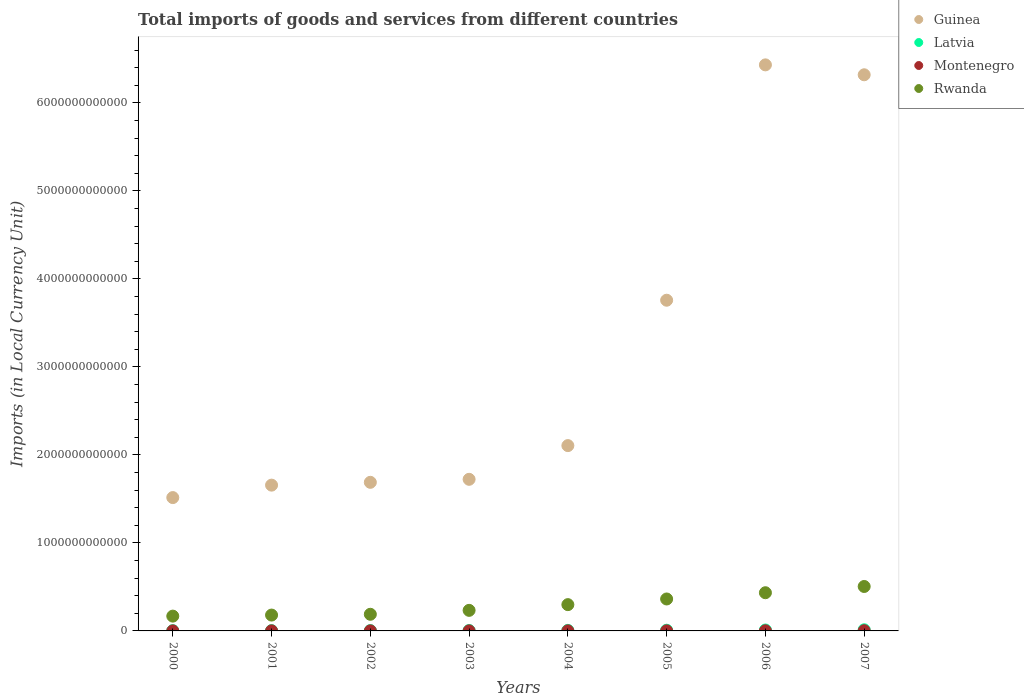How many different coloured dotlines are there?
Provide a short and direct response. 4. What is the Amount of goods and services imports in Rwanda in 2001?
Offer a very short reply. 1.80e+11. Across all years, what is the maximum Amount of goods and services imports in Latvia?
Your answer should be very brief. 1.30e+1. Across all years, what is the minimum Amount of goods and services imports in Rwanda?
Give a very brief answer. 1.68e+11. In which year was the Amount of goods and services imports in Rwanda maximum?
Your answer should be very brief. 2007. In which year was the Amount of goods and services imports in Montenegro minimum?
Your answer should be very brief. 2000. What is the total Amount of goods and services imports in Montenegro in the graph?
Make the answer very short. 8.97e+09. What is the difference between the Amount of goods and services imports in Montenegro in 2004 and that in 2006?
Your response must be concise. -7.30e+08. What is the difference between the Amount of goods and services imports in Latvia in 2003 and the Amount of goods and services imports in Rwanda in 2000?
Make the answer very short. -1.64e+11. What is the average Amount of goods and services imports in Guinea per year?
Ensure brevity in your answer.  3.15e+12. In the year 2003, what is the difference between the Amount of goods and services imports in Montenegro and Amount of goods and services imports in Rwanda?
Offer a very short reply. -2.33e+11. What is the ratio of the Amount of goods and services imports in Guinea in 2000 to that in 2006?
Provide a succinct answer. 0.24. Is the Amount of goods and services imports in Guinea in 2005 less than that in 2006?
Provide a succinct answer. Yes. What is the difference between the highest and the second highest Amount of goods and services imports in Rwanda?
Give a very brief answer. 7.10e+1. What is the difference between the highest and the lowest Amount of goods and services imports in Rwanda?
Offer a terse response. 3.37e+11. Does the Amount of goods and services imports in Montenegro monotonically increase over the years?
Give a very brief answer. No. Is the Amount of goods and services imports in Montenegro strictly greater than the Amount of goods and services imports in Guinea over the years?
Your answer should be very brief. No. Is the Amount of goods and services imports in Montenegro strictly less than the Amount of goods and services imports in Rwanda over the years?
Your answer should be very brief. Yes. How many dotlines are there?
Give a very brief answer. 4. How many years are there in the graph?
Keep it short and to the point. 8. What is the difference between two consecutive major ticks on the Y-axis?
Keep it short and to the point. 1.00e+12. Does the graph contain grids?
Ensure brevity in your answer.  No. Where does the legend appear in the graph?
Provide a succinct answer. Top right. How many legend labels are there?
Ensure brevity in your answer.  4. How are the legend labels stacked?
Your answer should be very brief. Vertical. What is the title of the graph?
Ensure brevity in your answer.  Total imports of goods and services from different countries. Does "High income: nonOECD" appear as one of the legend labels in the graph?
Your answer should be compact. No. What is the label or title of the Y-axis?
Offer a very short reply. Imports (in Local Currency Unit). What is the Imports (in Local Currency Unit) in Guinea in 2000?
Provide a short and direct response. 1.52e+12. What is the Imports (in Local Currency Unit) in Latvia in 2000?
Offer a very short reply. 3.07e+09. What is the Imports (in Local Currency Unit) of Montenegro in 2000?
Offer a very short reply. 5.45e+08. What is the Imports (in Local Currency Unit) in Rwanda in 2000?
Offer a terse response. 1.68e+11. What is the Imports (in Local Currency Unit) in Guinea in 2001?
Give a very brief answer. 1.66e+12. What is the Imports (in Local Currency Unit) of Latvia in 2001?
Give a very brief answer. 3.61e+09. What is the Imports (in Local Currency Unit) of Montenegro in 2001?
Keep it short and to the point. 8.03e+08. What is the Imports (in Local Currency Unit) of Rwanda in 2001?
Your answer should be compact. 1.80e+11. What is the Imports (in Local Currency Unit) of Guinea in 2002?
Offer a terse response. 1.69e+12. What is the Imports (in Local Currency Unit) of Latvia in 2002?
Your response must be concise. 3.92e+09. What is the Imports (in Local Currency Unit) of Montenegro in 2002?
Your answer should be very brief. 8.14e+08. What is the Imports (in Local Currency Unit) of Rwanda in 2002?
Your response must be concise. 1.89e+11. What is the Imports (in Local Currency Unit) in Guinea in 2003?
Your answer should be very brief. 1.72e+12. What is the Imports (in Local Currency Unit) of Latvia in 2003?
Offer a terse response. 4.65e+09. What is the Imports (in Local Currency Unit) in Montenegro in 2003?
Keep it short and to the point. 7.10e+08. What is the Imports (in Local Currency Unit) in Rwanda in 2003?
Your answer should be very brief. 2.34e+11. What is the Imports (in Local Currency Unit) in Guinea in 2004?
Your answer should be compact. 2.11e+12. What is the Imports (in Local Currency Unit) in Latvia in 2004?
Your answer should be compact. 6.04e+09. What is the Imports (in Local Currency Unit) of Montenegro in 2004?
Your answer should be compact. 9.70e+08. What is the Imports (in Local Currency Unit) in Rwanda in 2004?
Your answer should be compact. 2.99e+11. What is the Imports (in Local Currency Unit) in Guinea in 2005?
Your response must be concise. 3.76e+12. What is the Imports (in Local Currency Unit) in Latvia in 2005?
Your answer should be very brief. 7.84e+09. What is the Imports (in Local Currency Unit) in Montenegro in 2005?
Provide a succinct answer. 1.11e+09. What is the Imports (in Local Currency Unit) of Rwanda in 2005?
Your response must be concise. 3.63e+11. What is the Imports (in Local Currency Unit) in Guinea in 2006?
Your answer should be very brief. 6.43e+12. What is the Imports (in Local Currency Unit) in Latvia in 2006?
Keep it short and to the point. 1.04e+1. What is the Imports (in Local Currency Unit) in Montenegro in 2006?
Provide a succinct answer. 1.70e+09. What is the Imports (in Local Currency Unit) in Rwanda in 2006?
Your response must be concise. 4.34e+11. What is the Imports (in Local Currency Unit) in Guinea in 2007?
Give a very brief answer. 6.32e+12. What is the Imports (in Local Currency Unit) in Latvia in 2007?
Offer a terse response. 1.30e+1. What is the Imports (in Local Currency Unit) of Montenegro in 2007?
Offer a very short reply. 2.32e+09. What is the Imports (in Local Currency Unit) in Rwanda in 2007?
Your answer should be compact. 5.05e+11. Across all years, what is the maximum Imports (in Local Currency Unit) of Guinea?
Make the answer very short. 6.43e+12. Across all years, what is the maximum Imports (in Local Currency Unit) in Latvia?
Provide a succinct answer. 1.30e+1. Across all years, what is the maximum Imports (in Local Currency Unit) in Montenegro?
Ensure brevity in your answer.  2.32e+09. Across all years, what is the maximum Imports (in Local Currency Unit) in Rwanda?
Your answer should be very brief. 5.05e+11. Across all years, what is the minimum Imports (in Local Currency Unit) in Guinea?
Offer a very short reply. 1.52e+12. Across all years, what is the minimum Imports (in Local Currency Unit) of Latvia?
Keep it short and to the point. 3.07e+09. Across all years, what is the minimum Imports (in Local Currency Unit) in Montenegro?
Make the answer very short. 5.45e+08. Across all years, what is the minimum Imports (in Local Currency Unit) in Rwanda?
Your answer should be very brief. 1.68e+11. What is the total Imports (in Local Currency Unit) of Guinea in the graph?
Ensure brevity in your answer.  2.52e+13. What is the total Imports (in Local Currency Unit) in Latvia in the graph?
Give a very brief answer. 5.25e+1. What is the total Imports (in Local Currency Unit) in Montenegro in the graph?
Your response must be concise. 8.97e+09. What is the total Imports (in Local Currency Unit) in Rwanda in the graph?
Your answer should be very brief. 2.37e+12. What is the difference between the Imports (in Local Currency Unit) in Guinea in 2000 and that in 2001?
Your answer should be compact. -1.41e+11. What is the difference between the Imports (in Local Currency Unit) in Latvia in 2000 and that in 2001?
Your answer should be compact. -5.40e+08. What is the difference between the Imports (in Local Currency Unit) in Montenegro in 2000 and that in 2001?
Offer a very short reply. -2.58e+08. What is the difference between the Imports (in Local Currency Unit) in Rwanda in 2000 and that in 2001?
Provide a succinct answer. -1.19e+1. What is the difference between the Imports (in Local Currency Unit) in Guinea in 2000 and that in 2002?
Offer a terse response. -1.74e+11. What is the difference between the Imports (in Local Currency Unit) in Latvia in 2000 and that in 2002?
Keep it short and to the point. -8.49e+08. What is the difference between the Imports (in Local Currency Unit) of Montenegro in 2000 and that in 2002?
Offer a very short reply. -2.70e+08. What is the difference between the Imports (in Local Currency Unit) of Rwanda in 2000 and that in 2002?
Offer a very short reply. -2.09e+1. What is the difference between the Imports (in Local Currency Unit) of Guinea in 2000 and that in 2003?
Give a very brief answer. -2.08e+11. What is the difference between the Imports (in Local Currency Unit) of Latvia in 2000 and that in 2003?
Offer a terse response. -1.57e+09. What is the difference between the Imports (in Local Currency Unit) in Montenegro in 2000 and that in 2003?
Offer a very short reply. -1.65e+08. What is the difference between the Imports (in Local Currency Unit) of Rwanda in 2000 and that in 2003?
Offer a terse response. -6.55e+1. What is the difference between the Imports (in Local Currency Unit) in Guinea in 2000 and that in 2004?
Keep it short and to the point. -5.91e+11. What is the difference between the Imports (in Local Currency Unit) of Latvia in 2000 and that in 2004?
Offer a very short reply. -2.96e+09. What is the difference between the Imports (in Local Currency Unit) of Montenegro in 2000 and that in 2004?
Ensure brevity in your answer.  -4.25e+08. What is the difference between the Imports (in Local Currency Unit) in Rwanda in 2000 and that in 2004?
Offer a very short reply. -1.30e+11. What is the difference between the Imports (in Local Currency Unit) of Guinea in 2000 and that in 2005?
Offer a terse response. -2.24e+12. What is the difference between the Imports (in Local Currency Unit) in Latvia in 2000 and that in 2005?
Make the answer very short. -4.77e+09. What is the difference between the Imports (in Local Currency Unit) in Montenegro in 2000 and that in 2005?
Provide a succinct answer. -5.64e+08. What is the difference between the Imports (in Local Currency Unit) of Rwanda in 2000 and that in 2005?
Your response must be concise. -1.95e+11. What is the difference between the Imports (in Local Currency Unit) in Guinea in 2000 and that in 2006?
Your response must be concise. -4.92e+12. What is the difference between the Imports (in Local Currency Unit) in Latvia in 2000 and that in 2006?
Offer a terse response. -7.30e+09. What is the difference between the Imports (in Local Currency Unit) in Montenegro in 2000 and that in 2006?
Provide a short and direct response. -1.16e+09. What is the difference between the Imports (in Local Currency Unit) in Rwanda in 2000 and that in 2006?
Make the answer very short. -2.66e+11. What is the difference between the Imports (in Local Currency Unit) of Guinea in 2000 and that in 2007?
Your answer should be compact. -4.80e+12. What is the difference between the Imports (in Local Currency Unit) in Latvia in 2000 and that in 2007?
Give a very brief answer. -9.91e+09. What is the difference between the Imports (in Local Currency Unit) in Montenegro in 2000 and that in 2007?
Make the answer very short. -1.78e+09. What is the difference between the Imports (in Local Currency Unit) of Rwanda in 2000 and that in 2007?
Make the answer very short. -3.37e+11. What is the difference between the Imports (in Local Currency Unit) in Guinea in 2001 and that in 2002?
Your answer should be very brief. -3.20e+1. What is the difference between the Imports (in Local Currency Unit) of Latvia in 2001 and that in 2002?
Provide a short and direct response. -3.09e+08. What is the difference between the Imports (in Local Currency Unit) in Montenegro in 2001 and that in 2002?
Your answer should be compact. -1.17e+07. What is the difference between the Imports (in Local Currency Unit) of Rwanda in 2001 and that in 2002?
Your response must be concise. -9.00e+09. What is the difference between the Imports (in Local Currency Unit) of Guinea in 2001 and that in 2003?
Keep it short and to the point. -6.62e+1. What is the difference between the Imports (in Local Currency Unit) in Latvia in 2001 and that in 2003?
Ensure brevity in your answer.  -1.03e+09. What is the difference between the Imports (in Local Currency Unit) in Montenegro in 2001 and that in 2003?
Make the answer very short. 9.32e+07. What is the difference between the Imports (in Local Currency Unit) of Rwanda in 2001 and that in 2003?
Your answer should be very brief. -5.36e+1. What is the difference between the Imports (in Local Currency Unit) of Guinea in 2001 and that in 2004?
Offer a very short reply. -4.49e+11. What is the difference between the Imports (in Local Currency Unit) of Latvia in 2001 and that in 2004?
Your answer should be very brief. -2.42e+09. What is the difference between the Imports (in Local Currency Unit) in Montenegro in 2001 and that in 2004?
Provide a succinct answer. -1.67e+08. What is the difference between the Imports (in Local Currency Unit) of Rwanda in 2001 and that in 2004?
Make the answer very short. -1.19e+11. What is the difference between the Imports (in Local Currency Unit) of Guinea in 2001 and that in 2005?
Provide a succinct answer. -2.10e+12. What is the difference between the Imports (in Local Currency Unit) in Latvia in 2001 and that in 2005?
Your answer should be very brief. -4.23e+09. What is the difference between the Imports (in Local Currency Unit) in Montenegro in 2001 and that in 2005?
Provide a succinct answer. -3.06e+08. What is the difference between the Imports (in Local Currency Unit) in Rwanda in 2001 and that in 2005?
Offer a terse response. -1.83e+11. What is the difference between the Imports (in Local Currency Unit) of Guinea in 2001 and that in 2006?
Provide a short and direct response. -4.78e+12. What is the difference between the Imports (in Local Currency Unit) of Latvia in 2001 and that in 2006?
Provide a succinct answer. -6.76e+09. What is the difference between the Imports (in Local Currency Unit) in Montenegro in 2001 and that in 2006?
Provide a short and direct response. -8.97e+08. What is the difference between the Imports (in Local Currency Unit) in Rwanda in 2001 and that in 2006?
Offer a very short reply. -2.54e+11. What is the difference between the Imports (in Local Currency Unit) of Guinea in 2001 and that in 2007?
Offer a terse response. -4.66e+12. What is the difference between the Imports (in Local Currency Unit) of Latvia in 2001 and that in 2007?
Offer a very short reply. -9.37e+09. What is the difference between the Imports (in Local Currency Unit) in Montenegro in 2001 and that in 2007?
Your answer should be compact. -1.52e+09. What is the difference between the Imports (in Local Currency Unit) of Rwanda in 2001 and that in 2007?
Provide a succinct answer. -3.25e+11. What is the difference between the Imports (in Local Currency Unit) in Guinea in 2002 and that in 2003?
Give a very brief answer. -3.42e+1. What is the difference between the Imports (in Local Currency Unit) in Latvia in 2002 and that in 2003?
Make the answer very short. -7.26e+08. What is the difference between the Imports (in Local Currency Unit) of Montenegro in 2002 and that in 2003?
Your answer should be compact. 1.05e+08. What is the difference between the Imports (in Local Currency Unit) in Rwanda in 2002 and that in 2003?
Ensure brevity in your answer.  -4.46e+1. What is the difference between the Imports (in Local Currency Unit) of Guinea in 2002 and that in 2004?
Make the answer very short. -4.17e+11. What is the difference between the Imports (in Local Currency Unit) in Latvia in 2002 and that in 2004?
Keep it short and to the point. -2.11e+09. What is the difference between the Imports (in Local Currency Unit) in Montenegro in 2002 and that in 2004?
Your answer should be very brief. -1.55e+08. What is the difference between the Imports (in Local Currency Unit) of Rwanda in 2002 and that in 2004?
Your response must be concise. -1.10e+11. What is the difference between the Imports (in Local Currency Unit) in Guinea in 2002 and that in 2005?
Your answer should be compact. -2.07e+12. What is the difference between the Imports (in Local Currency Unit) in Latvia in 2002 and that in 2005?
Keep it short and to the point. -3.92e+09. What is the difference between the Imports (in Local Currency Unit) of Montenegro in 2002 and that in 2005?
Your answer should be compact. -2.94e+08. What is the difference between the Imports (in Local Currency Unit) in Rwanda in 2002 and that in 2005?
Your response must be concise. -1.74e+11. What is the difference between the Imports (in Local Currency Unit) in Guinea in 2002 and that in 2006?
Ensure brevity in your answer.  -4.74e+12. What is the difference between the Imports (in Local Currency Unit) of Latvia in 2002 and that in 2006?
Your answer should be very brief. -6.45e+09. What is the difference between the Imports (in Local Currency Unit) of Montenegro in 2002 and that in 2006?
Make the answer very short. -8.85e+08. What is the difference between the Imports (in Local Currency Unit) in Rwanda in 2002 and that in 2006?
Your answer should be very brief. -2.45e+11. What is the difference between the Imports (in Local Currency Unit) in Guinea in 2002 and that in 2007?
Give a very brief answer. -4.63e+12. What is the difference between the Imports (in Local Currency Unit) of Latvia in 2002 and that in 2007?
Your response must be concise. -9.06e+09. What is the difference between the Imports (in Local Currency Unit) of Montenegro in 2002 and that in 2007?
Offer a terse response. -1.51e+09. What is the difference between the Imports (in Local Currency Unit) of Rwanda in 2002 and that in 2007?
Your answer should be compact. -3.16e+11. What is the difference between the Imports (in Local Currency Unit) in Guinea in 2003 and that in 2004?
Your response must be concise. -3.83e+11. What is the difference between the Imports (in Local Currency Unit) of Latvia in 2003 and that in 2004?
Provide a short and direct response. -1.39e+09. What is the difference between the Imports (in Local Currency Unit) in Montenegro in 2003 and that in 2004?
Your answer should be compact. -2.60e+08. What is the difference between the Imports (in Local Currency Unit) in Rwanda in 2003 and that in 2004?
Offer a very short reply. -6.50e+1. What is the difference between the Imports (in Local Currency Unit) of Guinea in 2003 and that in 2005?
Your answer should be compact. -2.04e+12. What is the difference between the Imports (in Local Currency Unit) of Latvia in 2003 and that in 2005?
Offer a terse response. -3.19e+09. What is the difference between the Imports (in Local Currency Unit) of Montenegro in 2003 and that in 2005?
Ensure brevity in your answer.  -3.99e+08. What is the difference between the Imports (in Local Currency Unit) of Rwanda in 2003 and that in 2005?
Your answer should be very brief. -1.29e+11. What is the difference between the Imports (in Local Currency Unit) in Guinea in 2003 and that in 2006?
Provide a succinct answer. -4.71e+12. What is the difference between the Imports (in Local Currency Unit) in Latvia in 2003 and that in 2006?
Give a very brief answer. -5.72e+09. What is the difference between the Imports (in Local Currency Unit) in Montenegro in 2003 and that in 2006?
Offer a terse response. -9.90e+08. What is the difference between the Imports (in Local Currency Unit) in Rwanda in 2003 and that in 2006?
Your answer should be very brief. -2.00e+11. What is the difference between the Imports (in Local Currency Unit) of Guinea in 2003 and that in 2007?
Keep it short and to the point. -4.60e+12. What is the difference between the Imports (in Local Currency Unit) in Latvia in 2003 and that in 2007?
Your response must be concise. -8.34e+09. What is the difference between the Imports (in Local Currency Unit) in Montenegro in 2003 and that in 2007?
Provide a short and direct response. -1.61e+09. What is the difference between the Imports (in Local Currency Unit) of Rwanda in 2003 and that in 2007?
Offer a very short reply. -2.71e+11. What is the difference between the Imports (in Local Currency Unit) of Guinea in 2004 and that in 2005?
Provide a short and direct response. -1.65e+12. What is the difference between the Imports (in Local Currency Unit) in Latvia in 2004 and that in 2005?
Keep it short and to the point. -1.80e+09. What is the difference between the Imports (in Local Currency Unit) in Montenegro in 2004 and that in 2005?
Offer a terse response. -1.39e+08. What is the difference between the Imports (in Local Currency Unit) of Rwanda in 2004 and that in 2005?
Your response must be concise. -6.43e+1. What is the difference between the Imports (in Local Currency Unit) of Guinea in 2004 and that in 2006?
Provide a succinct answer. -4.33e+12. What is the difference between the Imports (in Local Currency Unit) in Latvia in 2004 and that in 2006?
Give a very brief answer. -4.34e+09. What is the difference between the Imports (in Local Currency Unit) in Montenegro in 2004 and that in 2006?
Keep it short and to the point. -7.30e+08. What is the difference between the Imports (in Local Currency Unit) in Rwanda in 2004 and that in 2006?
Provide a short and direct response. -1.35e+11. What is the difference between the Imports (in Local Currency Unit) in Guinea in 2004 and that in 2007?
Provide a succinct answer. -4.21e+12. What is the difference between the Imports (in Local Currency Unit) in Latvia in 2004 and that in 2007?
Offer a very short reply. -6.95e+09. What is the difference between the Imports (in Local Currency Unit) of Montenegro in 2004 and that in 2007?
Your answer should be compact. -1.35e+09. What is the difference between the Imports (in Local Currency Unit) of Rwanda in 2004 and that in 2007?
Offer a terse response. -2.06e+11. What is the difference between the Imports (in Local Currency Unit) in Guinea in 2005 and that in 2006?
Provide a succinct answer. -2.67e+12. What is the difference between the Imports (in Local Currency Unit) of Latvia in 2005 and that in 2006?
Offer a very short reply. -2.53e+09. What is the difference between the Imports (in Local Currency Unit) in Montenegro in 2005 and that in 2006?
Offer a very short reply. -5.91e+08. What is the difference between the Imports (in Local Currency Unit) in Rwanda in 2005 and that in 2006?
Your response must be concise. -7.10e+1. What is the difference between the Imports (in Local Currency Unit) of Guinea in 2005 and that in 2007?
Keep it short and to the point. -2.56e+12. What is the difference between the Imports (in Local Currency Unit) in Latvia in 2005 and that in 2007?
Give a very brief answer. -5.14e+09. What is the difference between the Imports (in Local Currency Unit) of Montenegro in 2005 and that in 2007?
Ensure brevity in your answer.  -1.22e+09. What is the difference between the Imports (in Local Currency Unit) of Rwanda in 2005 and that in 2007?
Your answer should be very brief. -1.42e+11. What is the difference between the Imports (in Local Currency Unit) in Guinea in 2006 and that in 2007?
Offer a terse response. 1.13e+11. What is the difference between the Imports (in Local Currency Unit) in Latvia in 2006 and that in 2007?
Provide a succinct answer. -2.61e+09. What is the difference between the Imports (in Local Currency Unit) in Montenegro in 2006 and that in 2007?
Offer a terse response. -6.24e+08. What is the difference between the Imports (in Local Currency Unit) of Rwanda in 2006 and that in 2007?
Your answer should be very brief. -7.10e+1. What is the difference between the Imports (in Local Currency Unit) of Guinea in 2000 and the Imports (in Local Currency Unit) of Latvia in 2001?
Your answer should be very brief. 1.51e+12. What is the difference between the Imports (in Local Currency Unit) of Guinea in 2000 and the Imports (in Local Currency Unit) of Montenegro in 2001?
Provide a short and direct response. 1.51e+12. What is the difference between the Imports (in Local Currency Unit) of Guinea in 2000 and the Imports (in Local Currency Unit) of Rwanda in 2001?
Provide a succinct answer. 1.34e+12. What is the difference between the Imports (in Local Currency Unit) in Latvia in 2000 and the Imports (in Local Currency Unit) in Montenegro in 2001?
Your answer should be compact. 2.27e+09. What is the difference between the Imports (in Local Currency Unit) of Latvia in 2000 and the Imports (in Local Currency Unit) of Rwanda in 2001?
Your answer should be very brief. -1.77e+11. What is the difference between the Imports (in Local Currency Unit) in Montenegro in 2000 and the Imports (in Local Currency Unit) in Rwanda in 2001?
Your answer should be very brief. -1.80e+11. What is the difference between the Imports (in Local Currency Unit) in Guinea in 2000 and the Imports (in Local Currency Unit) in Latvia in 2002?
Ensure brevity in your answer.  1.51e+12. What is the difference between the Imports (in Local Currency Unit) in Guinea in 2000 and the Imports (in Local Currency Unit) in Montenegro in 2002?
Your answer should be very brief. 1.51e+12. What is the difference between the Imports (in Local Currency Unit) of Guinea in 2000 and the Imports (in Local Currency Unit) of Rwanda in 2002?
Make the answer very short. 1.33e+12. What is the difference between the Imports (in Local Currency Unit) of Latvia in 2000 and the Imports (in Local Currency Unit) of Montenegro in 2002?
Keep it short and to the point. 2.26e+09. What is the difference between the Imports (in Local Currency Unit) of Latvia in 2000 and the Imports (in Local Currency Unit) of Rwanda in 2002?
Your answer should be very brief. -1.86e+11. What is the difference between the Imports (in Local Currency Unit) in Montenegro in 2000 and the Imports (in Local Currency Unit) in Rwanda in 2002?
Offer a very short reply. -1.89e+11. What is the difference between the Imports (in Local Currency Unit) of Guinea in 2000 and the Imports (in Local Currency Unit) of Latvia in 2003?
Provide a succinct answer. 1.51e+12. What is the difference between the Imports (in Local Currency Unit) in Guinea in 2000 and the Imports (in Local Currency Unit) in Montenegro in 2003?
Offer a very short reply. 1.51e+12. What is the difference between the Imports (in Local Currency Unit) of Guinea in 2000 and the Imports (in Local Currency Unit) of Rwanda in 2003?
Make the answer very short. 1.28e+12. What is the difference between the Imports (in Local Currency Unit) of Latvia in 2000 and the Imports (in Local Currency Unit) of Montenegro in 2003?
Give a very brief answer. 2.36e+09. What is the difference between the Imports (in Local Currency Unit) of Latvia in 2000 and the Imports (in Local Currency Unit) of Rwanda in 2003?
Provide a short and direct response. -2.31e+11. What is the difference between the Imports (in Local Currency Unit) in Montenegro in 2000 and the Imports (in Local Currency Unit) in Rwanda in 2003?
Offer a terse response. -2.33e+11. What is the difference between the Imports (in Local Currency Unit) of Guinea in 2000 and the Imports (in Local Currency Unit) of Latvia in 2004?
Your answer should be compact. 1.51e+12. What is the difference between the Imports (in Local Currency Unit) of Guinea in 2000 and the Imports (in Local Currency Unit) of Montenegro in 2004?
Your answer should be compact. 1.51e+12. What is the difference between the Imports (in Local Currency Unit) in Guinea in 2000 and the Imports (in Local Currency Unit) in Rwanda in 2004?
Your answer should be compact. 1.22e+12. What is the difference between the Imports (in Local Currency Unit) in Latvia in 2000 and the Imports (in Local Currency Unit) in Montenegro in 2004?
Give a very brief answer. 2.10e+09. What is the difference between the Imports (in Local Currency Unit) in Latvia in 2000 and the Imports (in Local Currency Unit) in Rwanda in 2004?
Your response must be concise. -2.96e+11. What is the difference between the Imports (in Local Currency Unit) in Montenegro in 2000 and the Imports (in Local Currency Unit) in Rwanda in 2004?
Keep it short and to the point. -2.98e+11. What is the difference between the Imports (in Local Currency Unit) of Guinea in 2000 and the Imports (in Local Currency Unit) of Latvia in 2005?
Keep it short and to the point. 1.51e+12. What is the difference between the Imports (in Local Currency Unit) in Guinea in 2000 and the Imports (in Local Currency Unit) in Montenegro in 2005?
Keep it short and to the point. 1.51e+12. What is the difference between the Imports (in Local Currency Unit) in Guinea in 2000 and the Imports (in Local Currency Unit) in Rwanda in 2005?
Offer a very short reply. 1.15e+12. What is the difference between the Imports (in Local Currency Unit) of Latvia in 2000 and the Imports (in Local Currency Unit) of Montenegro in 2005?
Your response must be concise. 1.97e+09. What is the difference between the Imports (in Local Currency Unit) in Latvia in 2000 and the Imports (in Local Currency Unit) in Rwanda in 2005?
Keep it short and to the point. -3.60e+11. What is the difference between the Imports (in Local Currency Unit) of Montenegro in 2000 and the Imports (in Local Currency Unit) of Rwanda in 2005?
Ensure brevity in your answer.  -3.62e+11. What is the difference between the Imports (in Local Currency Unit) in Guinea in 2000 and the Imports (in Local Currency Unit) in Latvia in 2006?
Give a very brief answer. 1.50e+12. What is the difference between the Imports (in Local Currency Unit) of Guinea in 2000 and the Imports (in Local Currency Unit) of Montenegro in 2006?
Keep it short and to the point. 1.51e+12. What is the difference between the Imports (in Local Currency Unit) of Guinea in 2000 and the Imports (in Local Currency Unit) of Rwanda in 2006?
Offer a terse response. 1.08e+12. What is the difference between the Imports (in Local Currency Unit) of Latvia in 2000 and the Imports (in Local Currency Unit) of Montenegro in 2006?
Your answer should be very brief. 1.37e+09. What is the difference between the Imports (in Local Currency Unit) in Latvia in 2000 and the Imports (in Local Currency Unit) in Rwanda in 2006?
Ensure brevity in your answer.  -4.31e+11. What is the difference between the Imports (in Local Currency Unit) of Montenegro in 2000 and the Imports (in Local Currency Unit) of Rwanda in 2006?
Make the answer very short. -4.33e+11. What is the difference between the Imports (in Local Currency Unit) in Guinea in 2000 and the Imports (in Local Currency Unit) in Latvia in 2007?
Offer a terse response. 1.50e+12. What is the difference between the Imports (in Local Currency Unit) of Guinea in 2000 and the Imports (in Local Currency Unit) of Montenegro in 2007?
Provide a succinct answer. 1.51e+12. What is the difference between the Imports (in Local Currency Unit) of Guinea in 2000 and the Imports (in Local Currency Unit) of Rwanda in 2007?
Your answer should be compact. 1.01e+12. What is the difference between the Imports (in Local Currency Unit) of Latvia in 2000 and the Imports (in Local Currency Unit) of Montenegro in 2007?
Your response must be concise. 7.50e+08. What is the difference between the Imports (in Local Currency Unit) in Latvia in 2000 and the Imports (in Local Currency Unit) in Rwanda in 2007?
Give a very brief answer. -5.02e+11. What is the difference between the Imports (in Local Currency Unit) in Montenegro in 2000 and the Imports (in Local Currency Unit) in Rwanda in 2007?
Your answer should be compact. -5.04e+11. What is the difference between the Imports (in Local Currency Unit) of Guinea in 2001 and the Imports (in Local Currency Unit) of Latvia in 2002?
Keep it short and to the point. 1.65e+12. What is the difference between the Imports (in Local Currency Unit) of Guinea in 2001 and the Imports (in Local Currency Unit) of Montenegro in 2002?
Ensure brevity in your answer.  1.66e+12. What is the difference between the Imports (in Local Currency Unit) of Guinea in 2001 and the Imports (in Local Currency Unit) of Rwanda in 2002?
Provide a succinct answer. 1.47e+12. What is the difference between the Imports (in Local Currency Unit) of Latvia in 2001 and the Imports (in Local Currency Unit) of Montenegro in 2002?
Your answer should be compact. 2.80e+09. What is the difference between the Imports (in Local Currency Unit) of Latvia in 2001 and the Imports (in Local Currency Unit) of Rwanda in 2002?
Provide a short and direct response. -1.85e+11. What is the difference between the Imports (in Local Currency Unit) of Montenegro in 2001 and the Imports (in Local Currency Unit) of Rwanda in 2002?
Provide a succinct answer. -1.88e+11. What is the difference between the Imports (in Local Currency Unit) of Guinea in 2001 and the Imports (in Local Currency Unit) of Latvia in 2003?
Ensure brevity in your answer.  1.65e+12. What is the difference between the Imports (in Local Currency Unit) in Guinea in 2001 and the Imports (in Local Currency Unit) in Montenegro in 2003?
Keep it short and to the point. 1.66e+12. What is the difference between the Imports (in Local Currency Unit) of Guinea in 2001 and the Imports (in Local Currency Unit) of Rwanda in 2003?
Ensure brevity in your answer.  1.42e+12. What is the difference between the Imports (in Local Currency Unit) in Latvia in 2001 and the Imports (in Local Currency Unit) in Montenegro in 2003?
Make the answer very short. 2.90e+09. What is the difference between the Imports (in Local Currency Unit) of Latvia in 2001 and the Imports (in Local Currency Unit) of Rwanda in 2003?
Offer a very short reply. -2.30e+11. What is the difference between the Imports (in Local Currency Unit) of Montenegro in 2001 and the Imports (in Local Currency Unit) of Rwanda in 2003?
Provide a succinct answer. -2.33e+11. What is the difference between the Imports (in Local Currency Unit) of Guinea in 2001 and the Imports (in Local Currency Unit) of Latvia in 2004?
Give a very brief answer. 1.65e+12. What is the difference between the Imports (in Local Currency Unit) in Guinea in 2001 and the Imports (in Local Currency Unit) in Montenegro in 2004?
Make the answer very short. 1.66e+12. What is the difference between the Imports (in Local Currency Unit) of Guinea in 2001 and the Imports (in Local Currency Unit) of Rwanda in 2004?
Make the answer very short. 1.36e+12. What is the difference between the Imports (in Local Currency Unit) of Latvia in 2001 and the Imports (in Local Currency Unit) of Montenegro in 2004?
Keep it short and to the point. 2.64e+09. What is the difference between the Imports (in Local Currency Unit) of Latvia in 2001 and the Imports (in Local Currency Unit) of Rwanda in 2004?
Offer a very short reply. -2.95e+11. What is the difference between the Imports (in Local Currency Unit) in Montenegro in 2001 and the Imports (in Local Currency Unit) in Rwanda in 2004?
Keep it short and to the point. -2.98e+11. What is the difference between the Imports (in Local Currency Unit) in Guinea in 2001 and the Imports (in Local Currency Unit) in Latvia in 2005?
Keep it short and to the point. 1.65e+12. What is the difference between the Imports (in Local Currency Unit) in Guinea in 2001 and the Imports (in Local Currency Unit) in Montenegro in 2005?
Keep it short and to the point. 1.66e+12. What is the difference between the Imports (in Local Currency Unit) of Guinea in 2001 and the Imports (in Local Currency Unit) of Rwanda in 2005?
Provide a short and direct response. 1.29e+12. What is the difference between the Imports (in Local Currency Unit) of Latvia in 2001 and the Imports (in Local Currency Unit) of Montenegro in 2005?
Your answer should be compact. 2.51e+09. What is the difference between the Imports (in Local Currency Unit) in Latvia in 2001 and the Imports (in Local Currency Unit) in Rwanda in 2005?
Provide a succinct answer. -3.59e+11. What is the difference between the Imports (in Local Currency Unit) in Montenegro in 2001 and the Imports (in Local Currency Unit) in Rwanda in 2005?
Keep it short and to the point. -3.62e+11. What is the difference between the Imports (in Local Currency Unit) in Guinea in 2001 and the Imports (in Local Currency Unit) in Latvia in 2006?
Give a very brief answer. 1.65e+12. What is the difference between the Imports (in Local Currency Unit) in Guinea in 2001 and the Imports (in Local Currency Unit) in Montenegro in 2006?
Your answer should be very brief. 1.66e+12. What is the difference between the Imports (in Local Currency Unit) of Guinea in 2001 and the Imports (in Local Currency Unit) of Rwanda in 2006?
Your response must be concise. 1.22e+12. What is the difference between the Imports (in Local Currency Unit) in Latvia in 2001 and the Imports (in Local Currency Unit) in Montenegro in 2006?
Provide a succinct answer. 1.91e+09. What is the difference between the Imports (in Local Currency Unit) in Latvia in 2001 and the Imports (in Local Currency Unit) in Rwanda in 2006?
Provide a short and direct response. -4.30e+11. What is the difference between the Imports (in Local Currency Unit) of Montenegro in 2001 and the Imports (in Local Currency Unit) of Rwanda in 2006?
Offer a very short reply. -4.33e+11. What is the difference between the Imports (in Local Currency Unit) of Guinea in 2001 and the Imports (in Local Currency Unit) of Latvia in 2007?
Your answer should be compact. 1.64e+12. What is the difference between the Imports (in Local Currency Unit) in Guinea in 2001 and the Imports (in Local Currency Unit) in Montenegro in 2007?
Offer a very short reply. 1.65e+12. What is the difference between the Imports (in Local Currency Unit) of Guinea in 2001 and the Imports (in Local Currency Unit) of Rwanda in 2007?
Offer a very short reply. 1.15e+12. What is the difference between the Imports (in Local Currency Unit) in Latvia in 2001 and the Imports (in Local Currency Unit) in Montenegro in 2007?
Offer a terse response. 1.29e+09. What is the difference between the Imports (in Local Currency Unit) in Latvia in 2001 and the Imports (in Local Currency Unit) in Rwanda in 2007?
Your response must be concise. -5.01e+11. What is the difference between the Imports (in Local Currency Unit) of Montenegro in 2001 and the Imports (in Local Currency Unit) of Rwanda in 2007?
Your response must be concise. -5.04e+11. What is the difference between the Imports (in Local Currency Unit) in Guinea in 2002 and the Imports (in Local Currency Unit) in Latvia in 2003?
Make the answer very short. 1.68e+12. What is the difference between the Imports (in Local Currency Unit) of Guinea in 2002 and the Imports (in Local Currency Unit) of Montenegro in 2003?
Keep it short and to the point. 1.69e+12. What is the difference between the Imports (in Local Currency Unit) of Guinea in 2002 and the Imports (in Local Currency Unit) of Rwanda in 2003?
Your response must be concise. 1.46e+12. What is the difference between the Imports (in Local Currency Unit) in Latvia in 2002 and the Imports (in Local Currency Unit) in Montenegro in 2003?
Ensure brevity in your answer.  3.21e+09. What is the difference between the Imports (in Local Currency Unit) of Latvia in 2002 and the Imports (in Local Currency Unit) of Rwanda in 2003?
Offer a terse response. -2.30e+11. What is the difference between the Imports (in Local Currency Unit) of Montenegro in 2002 and the Imports (in Local Currency Unit) of Rwanda in 2003?
Offer a terse response. -2.33e+11. What is the difference between the Imports (in Local Currency Unit) in Guinea in 2002 and the Imports (in Local Currency Unit) in Latvia in 2004?
Your response must be concise. 1.68e+12. What is the difference between the Imports (in Local Currency Unit) of Guinea in 2002 and the Imports (in Local Currency Unit) of Montenegro in 2004?
Provide a succinct answer. 1.69e+12. What is the difference between the Imports (in Local Currency Unit) in Guinea in 2002 and the Imports (in Local Currency Unit) in Rwanda in 2004?
Your answer should be compact. 1.39e+12. What is the difference between the Imports (in Local Currency Unit) of Latvia in 2002 and the Imports (in Local Currency Unit) of Montenegro in 2004?
Your answer should be compact. 2.95e+09. What is the difference between the Imports (in Local Currency Unit) of Latvia in 2002 and the Imports (in Local Currency Unit) of Rwanda in 2004?
Provide a succinct answer. -2.95e+11. What is the difference between the Imports (in Local Currency Unit) in Montenegro in 2002 and the Imports (in Local Currency Unit) in Rwanda in 2004?
Your response must be concise. -2.98e+11. What is the difference between the Imports (in Local Currency Unit) in Guinea in 2002 and the Imports (in Local Currency Unit) in Latvia in 2005?
Provide a short and direct response. 1.68e+12. What is the difference between the Imports (in Local Currency Unit) of Guinea in 2002 and the Imports (in Local Currency Unit) of Montenegro in 2005?
Offer a very short reply. 1.69e+12. What is the difference between the Imports (in Local Currency Unit) in Guinea in 2002 and the Imports (in Local Currency Unit) in Rwanda in 2005?
Give a very brief answer. 1.33e+12. What is the difference between the Imports (in Local Currency Unit) of Latvia in 2002 and the Imports (in Local Currency Unit) of Montenegro in 2005?
Your answer should be compact. 2.81e+09. What is the difference between the Imports (in Local Currency Unit) of Latvia in 2002 and the Imports (in Local Currency Unit) of Rwanda in 2005?
Make the answer very short. -3.59e+11. What is the difference between the Imports (in Local Currency Unit) of Montenegro in 2002 and the Imports (in Local Currency Unit) of Rwanda in 2005?
Your answer should be very brief. -3.62e+11. What is the difference between the Imports (in Local Currency Unit) of Guinea in 2002 and the Imports (in Local Currency Unit) of Latvia in 2006?
Offer a terse response. 1.68e+12. What is the difference between the Imports (in Local Currency Unit) of Guinea in 2002 and the Imports (in Local Currency Unit) of Montenegro in 2006?
Ensure brevity in your answer.  1.69e+12. What is the difference between the Imports (in Local Currency Unit) of Guinea in 2002 and the Imports (in Local Currency Unit) of Rwanda in 2006?
Ensure brevity in your answer.  1.25e+12. What is the difference between the Imports (in Local Currency Unit) in Latvia in 2002 and the Imports (in Local Currency Unit) in Montenegro in 2006?
Offer a terse response. 2.22e+09. What is the difference between the Imports (in Local Currency Unit) of Latvia in 2002 and the Imports (in Local Currency Unit) of Rwanda in 2006?
Provide a short and direct response. -4.30e+11. What is the difference between the Imports (in Local Currency Unit) in Montenegro in 2002 and the Imports (in Local Currency Unit) in Rwanda in 2006?
Keep it short and to the point. -4.33e+11. What is the difference between the Imports (in Local Currency Unit) of Guinea in 2002 and the Imports (in Local Currency Unit) of Latvia in 2007?
Make the answer very short. 1.68e+12. What is the difference between the Imports (in Local Currency Unit) of Guinea in 2002 and the Imports (in Local Currency Unit) of Montenegro in 2007?
Make the answer very short. 1.69e+12. What is the difference between the Imports (in Local Currency Unit) in Guinea in 2002 and the Imports (in Local Currency Unit) in Rwanda in 2007?
Provide a succinct answer. 1.18e+12. What is the difference between the Imports (in Local Currency Unit) of Latvia in 2002 and the Imports (in Local Currency Unit) of Montenegro in 2007?
Your response must be concise. 1.60e+09. What is the difference between the Imports (in Local Currency Unit) of Latvia in 2002 and the Imports (in Local Currency Unit) of Rwanda in 2007?
Your answer should be compact. -5.01e+11. What is the difference between the Imports (in Local Currency Unit) in Montenegro in 2002 and the Imports (in Local Currency Unit) in Rwanda in 2007?
Provide a short and direct response. -5.04e+11. What is the difference between the Imports (in Local Currency Unit) in Guinea in 2003 and the Imports (in Local Currency Unit) in Latvia in 2004?
Offer a terse response. 1.72e+12. What is the difference between the Imports (in Local Currency Unit) of Guinea in 2003 and the Imports (in Local Currency Unit) of Montenegro in 2004?
Ensure brevity in your answer.  1.72e+12. What is the difference between the Imports (in Local Currency Unit) of Guinea in 2003 and the Imports (in Local Currency Unit) of Rwanda in 2004?
Provide a short and direct response. 1.42e+12. What is the difference between the Imports (in Local Currency Unit) of Latvia in 2003 and the Imports (in Local Currency Unit) of Montenegro in 2004?
Offer a very short reply. 3.68e+09. What is the difference between the Imports (in Local Currency Unit) of Latvia in 2003 and the Imports (in Local Currency Unit) of Rwanda in 2004?
Provide a short and direct response. -2.94e+11. What is the difference between the Imports (in Local Currency Unit) in Montenegro in 2003 and the Imports (in Local Currency Unit) in Rwanda in 2004?
Provide a succinct answer. -2.98e+11. What is the difference between the Imports (in Local Currency Unit) in Guinea in 2003 and the Imports (in Local Currency Unit) in Latvia in 2005?
Offer a terse response. 1.72e+12. What is the difference between the Imports (in Local Currency Unit) of Guinea in 2003 and the Imports (in Local Currency Unit) of Montenegro in 2005?
Provide a succinct answer. 1.72e+12. What is the difference between the Imports (in Local Currency Unit) of Guinea in 2003 and the Imports (in Local Currency Unit) of Rwanda in 2005?
Give a very brief answer. 1.36e+12. What is the difference between the Imports (in Local Currency Unit) of Latvia in 2003 and the Imports (in Local Currency Unit) of Montenegro in 2005?
Make the answer very short. 3.54e+09. What is the difference between the Imports (in Local Currency Unit) in Latvia in 2003 and the Imports (in Local Currency Unit) in Rwanda in 2005?
Provide a short and direct response. -3.58e+11. What is the difference between the Imports (in Local Currency Unit) of Montenegro in 2003 and the Imports (in Local Currency Unit) of Rwanda in 2005?
Keep it short and to the point. -3.62e+11. What is the difference between the Imports (in Local Currency Unit) in Guinea in 2003 and the Imports (in Local Currency Unit) in Latvia in 2006?
Ensure brevity in your answer.  1.71e+12. What is the difference between the Imports (in Local Currency Unit) of Guinea in 2003 and the Imports (in Local Currency Unit) of Montenegro in 2006?
Provide a short and direct response. 1.72e+12. What is the difference between the Imports (in Local Currency Unit) in Guinea in 2003 and the Imports (in Local Currency Unit) in Rwanda in 2006?
Offer a very short reply. 1.29e+12. What is the difference between the Imports (in Local Currency Unit) of Latvia in 2003 and the Imports (in Local Currency Unit) of Montenegro in 2006?
Your answer should be very brief. 2.95e+09. What is the difference between the Imports (in Local Currency Unit) in Latvia in 2003 and the Imports (in Local Currency Unit) in Rwanda in 2006?
Your answer should be very brief. -4.29e+11. What is the difference between the Imports (in Local Currency Unit) of Montenegro in 2003 and the Imports (in Local Currency Unit) of Rwanda in 2006?
Offer a terse response. -4.33e+11. What is the difference between the Imports (in Local Currency Unit) in Guinea in 2003 and the Imports (in Local Currency Unit) in Latvia in 2007?
Make the answer very short. 1.71e+12. What is the difference between the Imports (in Local Currency Unit) of Guinea in 2003 and the Imports (in Local Currency Unit) of Montenegro in 2007?
Ensure brevity in your answer.  1.72e+12. What is the difference between the Imports (in Local Currency Unit) in Guinea in 2003 and the Imports (in Local Currency Unit) in Rwanda in 2007?
Offer a terse response. 1.22e+12. What is the difference between the Imports (in Local Currency Unit) of Latvia in 2003 and the Imports (in Local Currency Unit) of Montenegro in 2007?
Offer a very short reply. 2.32e+09. What is the difference between the Imports (in Local Currency Unit) of Latvia in 2003 and the Imports (in Local Currency Unit) of Rwanda in 2007?
Your response must be concise. -5.00e+11. What is the difference between the Imports (in Local Currency Unit) of Montenegro in 2003 and the Imports (in Local Currency Unit) of Rwanda in 2007?
Offer a very short reply. -5.04e+11. What is the difference between the Imports (in Local Currency Unit) of Guinea in 2004 and the Imports (in Local Currency Unit) of Latvia in 2005?
Your response must be concise. 2.10e+12. What is the difference between the Imports (in Local Currency Unit) of Guinea in 2004 and the Imports (in Local Currency Unit) of Montenegro in 2005?
Make the answer very short. 2.10e+12. What is the difference between the Imports (in Local Currency Unit) of Guinea in 2004 and the Imports (in Local Currency Unit) of Rwanda in 2005?
Offer a very short reply. 1.74e+12. What is the difference between the Imports (in Local Currency Unit) of Latvia in 2004 and the Imports (in Local Currency Unit) of Montenegro in 2005?
Your response must be concise. 4.93e+09. What is the difference between the Imports (in Local Currency Unit) in Latvia in 2004 and the Imports (in Local Currency Unit) in Rwanda in 2005?
Offer a terse response. -3.57e+11. What is the difference between the Imports (in Local Currency Unit) in Montenegro in 2004 and the Imports (in Local Currency Unit) in Rwanda in 2005?
Provide a succinct answer. -3.62e+11. What is the difference between the Imports (in Local Currency Unit) in Guinea in 2004 and the Imports (in Local Currency Unit) in Latvia in 2006?
Offer a very short reply. 2.10e+12. What is the difference between the Imports (in Local Currency Unit) of Guinea in 2004 and the Imports (in Local Currency Unit) of Montenegro in 2006?
Offer a very short reply. 2.10e+12. What is the difference between the Imports (in Local Currency Unit) in Guinea in 2004 and the Imports (in Local Currency Unit) in Rwanda in 2006?
Give a very brief answer. 1.67e+12. What is the difference between the Imports (in Local Currency Unit) of Latvia in 2004 and the Imports (in Local Currency Unit) of Montenegro in 2006?
Your response must be concise. 4.34e+09. What is the difference between the Imports (in Local Currency Unit) of Latvia in 2004 and the Imports (in Local Currency Unit) of Rwanda in 2006?
Ensure brevity in your answer.  -4.28e+11. What is the difference between the Imports (in Local Currency Unit) of Montenegro in 2004 and the Imports (in Local Currency Unit) of Rwanda in 2006?
Provide a short and direct response. -4.33e+11. What is the difference between the Imports (in Local Currency Unit) of Guinea in 2004 and the Imports (in Local Currency Unit) of Latvia in 2007?
Provide a short and direct response. 2.09e+12. What is the difference between the Imports (in Local Currency Unit) of Guinea in 2004 and the Imports (in Local Currency Unit) of Montenegro in 2007?
Your response must be concise. 2.10e+12. What is the difference between the Imports (in Local Currency Unit) in Guinea in 2004 and the Imports (in Local Currency Unit) in Rwanda in 2007?
Keep it short and to the point. 1.60e+12. What is the difference between the Imports (in Local Currency Unit) in Latvia in 2004 and the Imports (in Local Currency Unit) in Montenegro in 2007?
Your answer should be very brief. 3.71e+09. What is the difference between the Imports (in Local Currency Unit) of Latvia in 2004 and the Imports (in Local Currency Unit) of Rwanda in 2007?
Keep it short and to the point. -4.99e+11. What is the difference between the Imports (in Local Currency Unit) in Montenegro in 2004 and the Imports (in Local Currency Unit) in Rwanda in 2007?
Keep it short and to the point. -5.04e+11. What is the difference between the Imports (in Local Currency Unit) of Guinea in 2005 and the Imports (in Local Currency Unit) of Latvia in 2006?
Offer a very short reply. 3.75e+12. What is the difference between the Imports (in Local Currency Unit) of Guinea in 2005 and the Imports (in Local Currency Unit) of Montenegro in 2006?
Your answer should be very brief. 3.76e+12. What is the difference between the Imports (in Local Currency Unit) of Guinea in 2005 and the Imports (in Local Currency Unit) of Rwanda in 2006?
Make the answer very short. 3.32e+12. What is the difference between the Imports (in Local Currency Unit) in Latvia in 2005 and the Imports (in Local Currency Unit) in Montenegro in 2006?
Ensure brevity in your answer.  6.14e+09. What is the difference between the Imports (in Local Currency Unit) of Latvia in 2005 and the Imports (in Local Currency Unit) of Rwanda in 2006?
Give a very brief answer. -4.26e+11. What is the difference between the Imports (in Local Currency Unit) of Montenegro in 2005 and the Imports (in Local Currency Unit) of Rwanda in 2006?
Your response must be concise. -4.33e+11. What is the difference between the Imports (in Local Currency Unit) in Guinea in 2005 and the Imports (in Local Currency Unit) in Latvia in 2007?
Make the answer very short. 3.75e+12. What is the difference between the Imports (in Local Currency Unit) in Guinea in 2005 and the Imports (in Local Currency Unit) in Montenegro in 2007?
Offer a terse response. 3.76e+12. What is the difference between the Imports (in Local Currency Unit) in Guinea in 2005 and the Imports (in Local Currency Unit) in Rwanda in 2007?
Ensure brevity in your answer.  3.25e+12. What is the difference between the Imports (in Local Currency Unit) in Latvia in 2005 and the Imports (in Local Currency Unit) in Montenegro in 2007?
Provide a succinct answer. 5.52e+09. What is the difference between the Imports (in Local Currency Unit) in Latvia in 2005 and the Imports (in Local Currency Unit) in Rwanda in 2007?
Ensure brevity in your answer.  -4.97e+11. What is the difference between the Imports (in Local Currency Unit) of Montenegro in 2005 and the Imports (in Local Currency Unit) of Rwanda in 2007?
Provide a succinct answer. -5.04e+11. What is the difference between the Imports (in Local Currency Unit) of Guinea in 2006 and the Imports (in Local Currency Unit) of Latvia in 2007?
Provide a short and direct response. 6.42e+12. What is the difference between the Imports (in Local Currency Unit) in Guinea in 2006 and the Imports (in Local Currency Unit) in Montenegro in 2007?
Provide a short and direct response. 6.43e+12. What is the difference between the Imports (in Local Currency Unit) of Guinea in 2006 and the Imports (in Local Currency Unit) of Rwanda in 2007?
Keep it short and to the point. 5.93e+12. What is the difference between the Imports (in Local Currency Unit) in Latvia in 2006 and the Imports (in Local Currency Unit) in Montenegro in 2007?
Offer a very short reply. 8.05e+09. What is the difference between the Imports (in Local Currency Unit) of Latvia in 2006 and the Imports (in Local Currency Unit) of Rwanda in 2007?
Your answer should be compact. -4.95e+11. What is the difference between the Imports (in Local Currency Unit) of Montenegro in 2006 and the Imports (in Local Currency Unit) of Rwanda in 2007?
Provide a succinct answer. -5.03e+11. What is the average Imports (in Local Currency Unit) in Guinea per year?
Your answer should be compact. 3.15e+12. What is the average Imports (in Local Currency Unit) in Latvia per year?
Provide a short and direct response. 6.56e+09. What is the average Imports (in Local Currency Unit) of Montenegro per year?
Offer a terse response. 1.12e+09. What is the average Imports (in Local Currency Unit) in Rwanda per year?
Make the answer very short. 2.96e+11. In the year 2000, what is the difference between the Imports (in Local Currency Unit) in Guinea and Imports (in Local Currency Unit) in Latvia?
Provide a short and direct response. 1.51e+12. In the year 2000, what is the difference between the Imports (in Local Currency Unit) of Guinea and Imports (in Local Currency Unit) of Montenegro?
Your response must be concise. 1.51e+12. In the year 2000, what is the difference between the Imports (in Local Currency Unit) in Guinea and Imports (in Local Currency Unit) in Rwanda?
Provide a short and direct response. 1.35e+12. In the year 2000, what is the difference between the Imports (in Local Currency Unit) of Latvia and Imports (in Local Currency Unit) of Montenegro?
Ensure brevity in your answer.  2.53e+09. In the year 2000, what is the difference between the Imports (in Local Currency Unit) of Latvia and Imports (in Local Currency Unit) of Rwanda?
Provide a succinct answer. -1.65e+11. In the year 2000, what is the difference between the Imports (in Local Currency Unit) in Montenegro and Imports (in Local Currency Unit) in Rwanda?
Give a very brief answer. -1.68e+11. In the year 2001, what is the difference between the Imports (in Local Currency Unit) of Guinea and Imports (in Local Currency Unit) of Latvia?
Provide a succinct answer. 1.65e+12. In the year 2001, what is the difference between the Imports (in Local Currency Unit) of Guinea and Imports (in Local Currency Unit) of Montenegro?
Give a very brief answer. 1.66e+12. In the year 2001, what is the difference between the Imports (in Local Currency Unit) of Guinea and Imports (in Local Currency Unit) of Rwanda?
Give a very brief answer. 1.48e+12. In the year 2001, what is the difference between the Imports (in Local Currency Unit) in Latvia and Imports (in Local Currency Unit) in Montenegro?
Offer a very short reply. 2.81e+09. In the year 2001, what is the difference between the Imports (in Local Currency Unit) in Latvia and Imports (in Local Currency Unit) in Rwanda?
Make the answer very short. -1.76e+11. In the year 2001, what is the difference between the Imports (in Local Currency Unit) of Montenegro and Imports (in Local Currency Unit) of Rwanda?
Offer a terse response. -1.79e+11. In the year 2002, what is the difference between the Imports (in Local Currency Unit) of Guinea and Imports (in Local Currency Unit) of Latvia?
Your response must be concise. 1.68e+12. In the year 2002, what is the difference between the Imports (in Local Currency Unit) in Guinea and Imports (in Local Currency Unit) in Montenegro?
Keep it short and to the point. 1.69e+12. In the year 2002, what is the difference between the Imports (in Local Currency Unit) in Guinea and Imports (in Local Currency Unit) in Rwanda?
Offer a very short reply. 1.50e+12. In the year 2002, what is the difference between the Imports (in Local Currency Unit) of Latvia and Imports (in Local Currency Unit) of Montenegro?
Make the answer very short. 3.11e+09. In the year 2002, what is the difference between the Imports (in Local Currency Unit) of Latvia and Imports (in Local Currency Unit) of Rwanda?
Offer a very short reply. -1.85e+11. In the year 2002, what is the difference between the Imports (in Local Currency Unit) in Montenegro and Imports (in Local Currency Unit) in Rwanda?
Make the answer very short. -1.88e+11. In the year 2003, what is the difference between the Imports (in Local Currency Unit) in Guinea and Imports (in Local Currency Unit) in Latvia?
Offer a very short reply. 1.72e+12. In the year 2003, what is the difference between the Imports (in Local Currency Unit) in Guinea and Imports (in Local Currency Unit) in Montenegro?
Provide a short and direct response. 1.72e+12. In the year 2003, what is the difference between the Imports (in Local Currency Unit) of Guinea and Imports (in Local Currency Unit) of Rwanda?
Make the answer very short. 1.49e+12. In the year 2003, what is the difference between the Imports (in Local Currency Unit) in Latvia and Imports (in Local Currency Unit) in Montenegro?
Ensure brevity in your answer.  3.94e+09. In the year 2003, what is the difference between the Imports (in Local Currency Unit) of Latvia and Imports (in Local Currency Unit) of Rwanda?
Offer a terse response. -2.29e+11. In the year 2003, what is the difference between the Imports (in Local Currency Unit) in Montenegro and Imports (in Local Currency Unit) in Rwanda?
Your answer should be very brief. -2.33e+11. In the year 2004, what is the difference between the Imports (in Local Currency Unit) in Guinea and Imports (in Local Currency Unit) in Latvia?
Your answer should be very brief. 2.10e+12. In the year 2004, what is the difference between the Imports (in Local Currency Unit) of Guinea and Imports (in Local Currency Unit) of Montenegro?
Provide a short and direct response. 2.11e+12. In the year 2004, what is the difference between the Imports (in Local Currency Unit) of Guinea and Imports (in Local Currency Unit) of Rwanda?
Give a very brief answer. 1.81e+12. In the year 2004, what is the difference between the Imports (in Local Currency Unit) of Latvia and Imports (in Local Currency Unit) of Montenegro?
Make the answer very short. 5.07e+09. In the year 2004, what is the difference between the Imports (in Local Currency Unit) in Latvia and Imports (in Local Currency Unit) in Rwanda?
Provide a short and direct response. -2.93e+11. In the year 2004, what is the difference between the Imports (in Local Currency Unit) in Montenegro and Imports (in Local Currency Unit) in Rwanda?
Keep it short and to the point. -2.98e+11. In the year 2005, what is the difference between the Imports (in Local Currency Unit) of Guinea and Imports (in Local Currency Unit) of Latvia?
Provide a succinct answer. 3.75e+12. In the year 2005, what is the difference between the Imports (in Local Currency Unit) of Guinea and Imports (in Local Currency Unit) of Montenegro?
Provide a short and direct response. 3.76e+12. In the year 2005, what is the difference between the Imports (in Local Currency Unit) in Guinea and Imports (in Local Currency Unit) in Rwanda?
Your response must be concise. 3.40e+12. In the year 2005, what is the difference between the Imports (in Local Currency Unit) of Latvia and Imports (in Local Currency Unit) of Montenegro?
Make the answer very short. 6.73e+09. In the year 2005, what is the difference between the Imports (in Local Currency Unit) of Latvia and Imports (in Local Currency Unit) of Rwanda?
Give a very brief answer. -3.55e+11. In the year 2005, what is the difference between the Imports (in Local Currency Unit) of Montenegro and Imports (in Local Currency Unit) of Rwanda?
Offer a terse response. -3.62e+11. In the year 2006, what is the difference between the Imports (in Local Currency Unit) in Guinea and Imports (in Local Currency Unit) in Latvia?
Give a very brief answer. 6.42e+12. In the year 2006, what is the difference between the Imports (in Local Currency Unit) of Guinea and Imports (in Local Currency Unit) of Montenegro?
Your response must be concise. 6.43e+12. In the year 2006, what is the difference between the Imports (in Local Currency Unit) of Guinea and Imports (in Local Currency Unit) of Rwanda?
Ensure brevity in your answer.  6.00e+12. In the year 2006, what is the difference between the Imports (in Local Currency Unit) of Latvia and Imports (in Local Currency Unit) of Montenegro?
Keep it short and to the point. 8.67e+09. In the year 2006, what is the difference between the Imports (in Local Currency Unit) in Latvia and Imports (in Local Currency Unit) in Rwanda?
Ensure brevity in your answer.  -4.24e+11. In the year 2006, what is the difference between the Imports (in Local Currency Unit) of Montenegro and Imports (in Local Currency Unit) of Rwanda?
Give a very brief answer. -4.32e+11. In the year 2007, what is the difference between the Imports (in Local Currency Unit) of Guinea and Imports (in Local Currency Unit) of Latvia?
Make the answer very short. 6.31e+12. In the year 2007, what is the difference between the Imports (in Local Currency Unit) in Guinea and Imports (in Local Currency Unit) in Montenegro?
Offer a very short reply. 6.32e+12. In the year 2007, what is the difference between the Imports (in Local Currency Unit) in Guinea and Imports (in Local Currency Unit) in Rwanda?
Provide a succinct answer. 5.82e+12. In the year 2007, what is the difference between the Imports (in Local Currency Unit) in Latvia and Imports (in Local Currency Unit) in Montenegro?
Keep it short and to the point. 1.07e+1. In the year 2007, what is the difference between the Imports (in Local Currency Unit) in Latvia and Imports (in Local Currency Unit) in Rwanda?
Give a very brief answer. -4.92e+11. In the year 2007, what is the difference between the Imports (in Local Currency Unit) of Montenegro and Imports (in Local Currency Unit) of Rwanda?
Ensure brevity in your answer.  -5.03e+11. What is the ratio of the Imports (in Local Currency Unit) of Guinea in 2000 to that in 2001?
Provide a short and direct response. 0.91. What is the ratio of the Imports (in Local Currency Unit) of Latvia in 2000 to that in 2001?
Your response must be concise. 0.85. What is the ratio of the Imports (in Local Currency Unit) in Montenegro in 2000 to that in 2001?
Your response must be concise. 0.68. What is the ratio of the Imports (in Local Currency Unit) in Rwanda in 2000 to that in 2001?
Offer a terse response. 0.93. What is the ratio of the Imports (in Local Currency Unit) in Guinea in 2000 to that in 2002?
Offer a very short reply. 0.9. What is the ratio of the Imports (in Local Currency Unit) of Latvia in 2000 to that in 2002?
Keep it short and to the point. 0.78. What is the ratio of the Imports (in Local Currency Unit) in Montenegro in 2000 to that in 2002?
Your answer should be very brief. 0.67. What is the ratio of the Imports (in Local Currency Unit) in Rwanda in 2000 to that in 2002?
Offer a terse response. 0.89. What is the ratio of the Imports (in Local Currency Unit) of Guinea in 2000 to that in 2003?
Provide a short and direct response. 0.88. What is the ratio of the Imports (in Local Currency Unit) of Latvia in 2000 to that in 2003?
Ensure brevity in your answer.  0.66. What is the ratio of the Imports (in Local Currency Unit) of Montenegro in 2000 to that in 2003?
Ensure brevity in your answer.  0.77. What is the ratio of the Imports (in Local Currency Unit) in Rwanda in 2000 to that in 2003?
Make the answer very short. 0.72. What is the ratio of the Imports (in Local Currency Unit) of Guinea in 2000 to that in 2004?
Provide a succinct answer. 0.72. What is the ratio of the Imports (in Local Currency Unit) of Latvia in 2000 to that in 2004?
Provide a succinct answer. 0.51. What is the ratio of the Imports (in Local Currency Unit) of Montenegro in 2000 to that in 2004?
Keep it short and to the point. 0.56. What is the ratio of the Imports (in Local Currency Unit) in Rwanda in 2000 to that in 2004?
Provide a short and direct response. 0.56. What is the ratio of the Imports (in Local Currency Unit) in Guinea in 2000 to that in 2005?
Provide a short and direct response. 0.4. What is the ratio of the Imports (in Local Currency Unit) in Latvia in 2000 to that in 2005?
Your answer should be compact. 0.39. What is the ratio of the Imports (in Local Currency Unit) of Montenegro in 2000 to that in 2005?
Give a very brief answer. 0.49. What is the ratio of the Imports (in Local Currency Unit) in Rwanda in 2000 to that in 2005?
Give a very brief answer. 0.46. What is the ratio of the Imports (in Local Currency Unit) of Guinea in 2000 to that in 2006?
Your response must be concise. 0.24. What is the ratio of the Imports (in Local Currency Unit) of Latvia in 2000 to that in 2006?
Your response must be concise. 0.3. What is the ratio of the Imports (in Local Currency Unit) of Montenegro in 2000 to that in 2006?
Your response must be concise. 0.32. What is the ratio of the Imports (in Local Currency Unit) of Rwanda in 2000 to that in 2006?
Offer a very short reply. 0.39. What is the ratio of the Imports (in Local Currency Unit) of Guinea in 2000 to that in 2007?
Ensure brevity in your answer.  0.24. What is the ratio of the Imports (in Local Currency Unit) of Latvia in 2000 to that in 2007?
Your answer should be very brief. 0.24. What is the ratio of the Imports (in Local Currency Unit) of Montenegro in 2000 to that in 2007?
Your answer should be compact. 0.23. What is the ratio of the Imports (in Local Currency Unit) in Rwanda in 2000 to that in 2007?
Ensure brevity in your answer.  0.33. What is the ratio of the Imports (in Local Currency Unit) of Latvia in 2001 to that in 2002?
Ensure brevity in your answer.  0.92. What is the ratio of the Imports (in Local Currency Unit) in Montenegro in 2001 to that in 2002?
Ensure brevity in your answer.  0.99. What is the ratio of the Imports (in Local Currency Unit) in Guinea in 2001 to that in 2003?
Provide a succinct answer. 0.96. What is the ratio of the Imports (in Local Currency Unit) in Latvia in 2001 to that in 2003?
Offer a terse response. 0.78. What is the ratio of the Imports (in Local Currency Unit) in Montenegro in 2001 to that in 2003?
Your answer should be very brief. 1.13. What is the ratio of the Imports (in Local Currency Unit) in Rwanda in 2001 to that in 2003?
Give a very brief answer. 0.77. What is the ratio of the Imports (in Local Currency Unit) in Guinea in 2001 to that in 2004?
Your answer should be very brief. 0.79. What is the ratio of the Imports (in Local Currency Unit) in Latvia in 2001 to that in 2004?
Provide a succinct answer. 0.6. What is the ratio of the Imports (in Local Currency Unit) of Montenegro in 2001 to that in 2004?
Provide a short and direct response. 0.83. What is the ratio of the Imports (in Local Currency Unit) of Rwanda in 2001 to that in 2004?
Provide a succinct answer. 0.6. What is the ratio of the Imports (in Local Currency Unit) in Guinea in 2001 to that in 2005?
Give a very brief answer. 0.44. What is the ratio of the Imports (in Local Currency Unit) in Latvia in 2001 to that in 2005?
Give a very brief answer. 0.46. What is the ratio of the Imports (in Local Currency Unit) of Montenegro in 2001 to that in 2005?
Ensure brevity in your answer.  0.72. What is the ratio of the Imports (in Local Currency Unit) in Rwanda in 2001 to that in 2005?
Keep it short and to the point. 0.5. What is the ratio of the Imports (in Local Currency Unit) in Guinea in 2001 to that in 2006?
Provide a succinct answer. 0.26. What is the ratio of the Imports (in Local Currency Unit) of Latvia in 2001 to that in 2006?
Ensure brevity in your answer.  0.35. What is the ratio of the Imports (in Local Currency Unit) in Montenegro in 2001 to that in 2006?
Your answer should be very brief. 0.47. What is the ratio of the Imports (in Local Currency Unit) of Rwanda in 2001 to that in 2006?
Make the answer very short. 0.41. What is the ratio of the Imports (in Local Currency Unit) in Guinea in 2001 to that in 2007?
Your answer should be very brief. 0.26. What is the ratio of the Imports (in Local Currency Unit) in Latvia in 2001 to that in 2007?
Keep it short and to the point. 0.28. What is the ratio of the Imports (in Local Currency Unit) in Montenegro in 2001 to that in 2007?
Give a very brief answer. 0.35. What is the ratio of the Imports (in Local Currency Unit) in Rwanda in 2001 to that in 2007?
Give a very brief answer. 0.36. What is the ratio of the Imports (in Local Currency Unit) in Guinea in 2002 to that in 2003?
Your answer should be compact. 0.98. What is the ratio of the Imports (in Local Currency Unit) in Latvia in 2002 to that in 2003?
Give a very brief answer. 0.84. What is the ratio of the Imports (in Local Currency Unit) of Montenegro in 2002 to that in 2003?
Make the answer very short. 1.15. What is the ratio of the Imports (in Local Currency Unit) in Rwanda in 2002 to that in 2003?
Offer a terse response. 0.81. What is the ratio of the Imports (in Local Currency Unit) of Guinea in 2002 to that in 2004?
Give a very brief answer. 0.8. What is the ratio of the Imports (in Local Currency Unit) of Latvia in 2002 to that in 2004?
Make the answer very short. 0.65. What is the ratio of the Imports (in Local Currency Unit) in Montenegro in 2002 to that in 2004?
Offer a terse response. 0.84. What is the ratio of the Imports (in Local Currency Unit) in Rwanda in 2002 to that in 2004?
Offer a terse response. 0.63. What is the ratio of the Imports (in Local Currency Unit) in Guinea in 2002 to that in 2005?
Your response must be concise. 0.45. What is the ratio of the Imports (in Local Currency Unit) of Latvia in 2002 to that in 2005?
Offer a terse response. 0.5. What is the ratio of the Imports (in Local Currency Unit) of Montenegro in 2002 to that in 2005?
Your answer should be very brief. 0.73. What is the ratio of the Imports (in Local Currency Unit) in Rwanda in 2002 to that in 2005?
Provide a short and direct response. 0.52. What is the ratio of the Imports (in Local Currency Unit) of Guinea in 2002 to that in 2006?
Give a very brief answer. 0.26. What is the ratio of the Imports (in Local Currency Unit) in Latvia in 2002 to that in 2006?
Make the answer very short. 0.38. What is the ratio of the Imports (in Local Currency Unit) of Montenegro in 2002 to that in 2006?
Provide a short and direct response. 0.48. What is the ratio of the Imports (in Local Currency Unit) of Rwanda in 2002 to that in 2006?
Offer a terse response. 0.44. What is the ratio of the Imports (in Local Currency Unit) of Guinea in 2002 to that in 2007?
Provide a succinct answer. 0.27. What is the ratio of the Imports (in Local Currency Unit) of Latvia in 2002 to that in 2007?
Ensure brevity in your answer.  0.3. What is the ratio of the Imports (in Local Currency Unit) of Montenegro in 2002 to that in 2007?
Give a very brief answer. 0.35. What is the ratio of the Imports (in Local Currency Unit) in Rwanda in 2002 to that in 2007?
Ensure brevity in your answer.  0.37. What is the ratio of the Imports (in Local Currency Unit) in Guinea in 2003 to that in 2004?
Provide a short and direct response. 0.82. What is the ratio of the Imports (in Local Currency Unit) in Latvia in 2003 to that in 2004?
Offer a very short reply. 0.77. What is the ratio of the Imports (in Local Currency Unit) of Montenegro in 2003 to that in 2004?
Your answer should be compact. 0.73. What is the ratio of the Imports (in Local Currency Unit) of Rwanda in 2003 to that in 2004?
Give a very brief answer. 0.78. What is the ratio of the Imports (in Local Currency Unit) in Guinea in 2003 to that in 2005?
Provide a succinct answer. 0.46. What is the ratio of the Imports (in Local Currency Unit) in Latvia in 2003 to that in 2005?
Make the answer very short. 0.59. What is the ratio of the Imports (in Local Currency Unit) of Montenegro in 2003 to that in 2005?
Your answer should be very brief. 0.64. What is the ratio of the Imports (in Local Currency Unit) in Rwanda in 2003 to that in 2005?
Ensure brevity in your answer.  0.64. What is the ratio of the Imports (in Local Currency Unit) of Guinea in 2003 to that in 2006?
Offer a terse response. 0.27. What is the ratio of the Imports (in Local Currency Unit) in Latvia in 2003 to that in 2006?
Provide a succinct answer. 0.45. What is the ratio of the Imports (in Local Currency Unit) in Montenegro in 2003 to that in 2006?
Offer a terse response. 0.42. What is the ratio of the Imports (in Local Currency Unit) of Rwanda in 2003 to that in 2006?
Keep it short and to the point. 0.54. What is the ratio of the Imports (in Local Currency Unit) in Guinea in 2003 to that in 2007?
Your response must be concise. 0.27. What is the ratio of the Imports (in Local Currency Unit) of Latvia in 2003 to that in 2007?
Provide a short and direct response. 0.36. What is the ratio of the Imports (in Local Currency Unit) of Montenegro in 2003 to that in 2007?
Your answer should be compact. 0.31. What is the ratio of the Imports (in Local Currency Unit) of Rwanda in 2003 to that in 2007?
Ensure brevity in your answer.  0.46. What is the ratio of the Imports (in Local Currency Unit) of Guinea in 2004 to that in 2005?
Offer a very short reply. 0.56. What is the ratio of the Imports (in Local Currency Unit) in Latvia in 2004 to that in 2005?
Make the answer very short. 0.77. What is the ratio of the Imports (in Local Currency Unit) in Montenegro in 2004 to that in 2005?
Provide a short and direct response. 0.88. What is the ratio of the Imports (in Local Currency Unit) of Rwanda in 2004 to that in 2005?
Your answer should be compact. 0.82. What is the ratio of the Imports (in Local Currency Unit) of Guinea in 2004 to that in 2006?
Your answer should be compact. 0.33. What is the ratio of the Imports (in Local Currency Unit) in Latvia in 2004 to that in 2006?
Your answer should be very brief. 0.58. What is the ratio of the Imports (in Local Currency Unit) in Montenegro in 2004 to that in 2006?
Make the answer very short. 0.57. What is the ratio of the Imports (in Local Currency Unit) in Rwanda in 2004 to that in 2006?
Your answer should be very brief. 0.69. What is the ratio of the Imports (in Local Currency Unit) in Guinea in 2004 to that in 2007?
Ensure brevity in your answer.  0.33. What is the ratio of the Imports (in Local Currency Unit) in Latvia in 2004 to that in 2007?
Keep it short and to the point. 0.46. What is the ratio of the Imports (in Local Currency Unit) in Montenegro in 2004 to that in 2007?
Keep it short and to the point. 0.42. What is the ratio of the Imports (in Local Currency Unit) of Rwanda in 2004 to that in 2007?
Your answer should be very brief. 0.59. What is the ratio of the Imports (in Local Currency Unit) of Guinea in 2005 to that in 2006?
Keep it short and to the point. 0.58. What is the ratio of the Imports (in Local Currency Unit) of Latvia in 2005 to that in 2006?
Your answer should be compact. 0.76. What is the ratio of the Imports (in Local Currency Unit) of Montenegro in 2005 to that in 2006?
Offer a terse response. 0.65. What is the ratio of the Imports (in Local Currency Unit) in Rwanda in 2005 to that in 2006?
Offer a terse response. 0.84. What is the ratio of the Imports (in Local Currency Unit) in Guinea in 2005 to that in 2007?
Ensure brevity in your answer.  0.59. What is the ratio of the Imports (in Local Currency Unit) of Latvia in 2005 to that in 2007?
Your answer should be compact. 0.6. What is the ratio of the Imports (in Local Currency Unit) in Montenegro in 2005 to that in 2007?
Offer a very short reply. 0.48. What is the ratio of the Imports (in Local Currency Unit) in Rwanda in 2005 to that in 2007?
Provide a succinct answer. 0.72. What is the ratio of the Imports (in Local Currency Unit) in Guinea in 2006 to that in 2007?
Your answer should be compact. 1.02. What is the ratio of the Imports (in Local Currency Unit) in Latvia in 2006 to that in 2007?
Make the answer very short. 0.8. What is the ratio of the Imports (in Local Currency Unit) in Montenegro in 2006 to that in 2007?
Offer a very short reply. 0.73. What is the ratio of the Imports (in Local Currency Unit) in Rwanda in 2006 to that in 2007?
Give a very brief answer. 0.86. What is the difference between the highest and the second highest Imports (in Local Currency Unit) in Guinea?
Offer a terse response. 1.13e+11. What is the difference between the highest and the second highest Imports (in Local Currency Unit) of Latvia?
Your answer should be very brief. 2.61e+09. What is the difference between the highest and the second highest Imports (in Local Currency Unit) of Montenegro?
Make the answer very short. 6.24e+08. What is the difference between the highest and the second highest Imports (in Local Currency Unit) of Rwanda?
Give a very brief answer. 7.10e+1. What is the difference between the highest and the lowest Imports (in Local Currency Unit) of Guinea?
Ensure brevity in your answer.  4.92e+12. What is the difference between the highest and the lowest Imports (in Local Currency Unit) of Latvia?
Ensure brevity in your answer.  9.91e+09. What is the difference between the highest and the lowest Imports (in Local Currency Unit) in Montenegro?
Make the answer very short. 1.78e+09. What is the difference between the highest and the lowest Imports (in Local Currency Unit) in Rwanda?
Ensure brevity in your answer.  3.37e+11. 